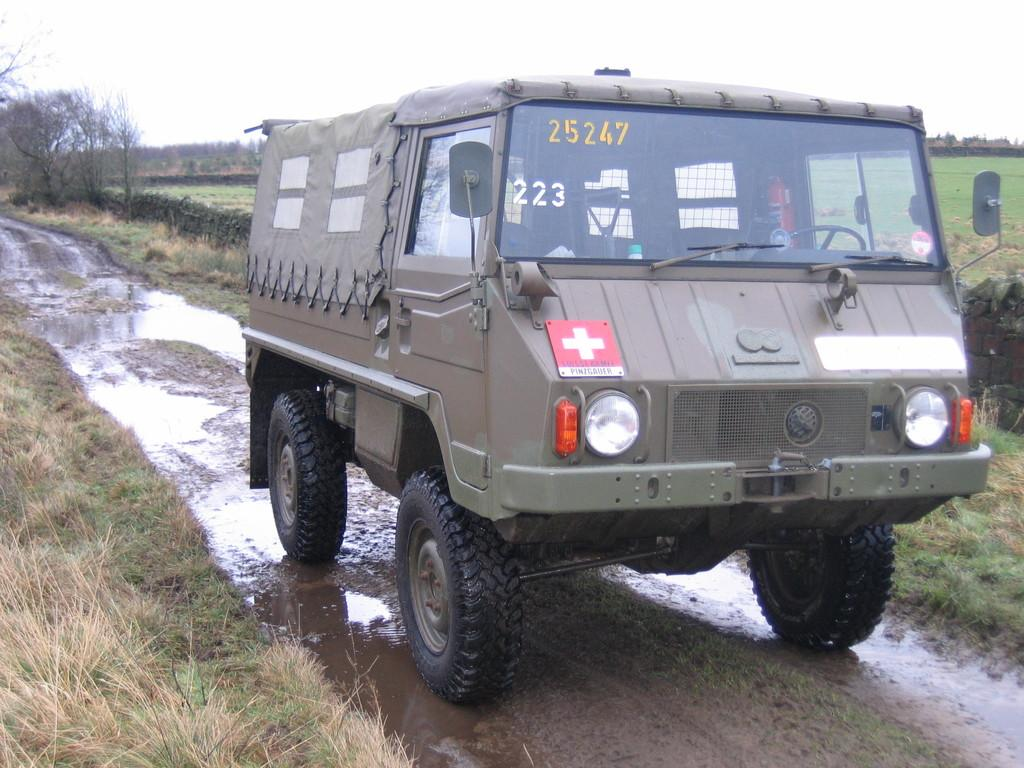What is the main subject in the image? There is a vehicle in the image. What can be seen beneath the vehicle? The ground is visible in the image. What is the body of water in the image? There is water in the image. What type of vegetation is present in the image? Grass, plants, and trees are visible in the image. What is visible in the background of the image? The sky is visible in the background of the image. What is the opinion of the cakes about the vehicle in the image? There are no cakes present in the image, so it is not possible to determine their opinion about the vehicle. 